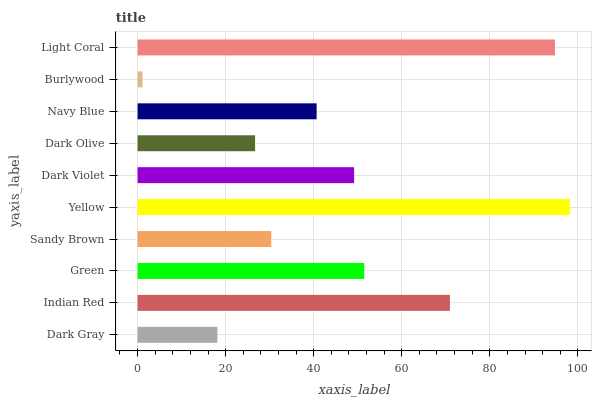Is Burlywood the minimum?
Answer yes or no. Yes. Is Yellow the maximum?
Answer yes or no. Yes. Is Indian Red the minimum?
Answer yes or no. No. Is Indian Red the maximum?
Answer yes or no. No. Is Indian Red greater than Dark Gray?
Answer yes or no. Yes. Is Dark Gray less than Indian Red?
Answer yes or no. Yes. Is Dark Gray greater than Indian Red?
Answer yes or no. No. Is Indian Red less than Dark Gray?
Answer yes or no. No. Is Dark Violet the high median?
Answer yes or no. Yes. Is Navy Blue the low median?
Answer yes or no. Yes. Is Yellow the high median?
Answer yes or no. No. Is Green the low median?
Answer yes or no. No. 